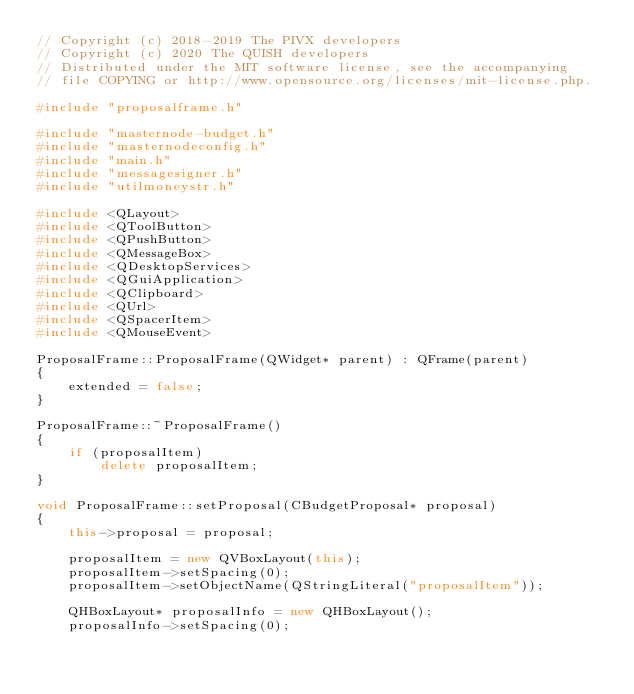<code> <loc_0><loc_0><loc_500><loc_500><_C++_>// Copyright (c) 2018-2019 The PIVX developers
// Copyright (c) 2020 The QUISH developers
// Distributed under the MIT software license, see the accompanying
// file COPYING or http://www.opensource.org/licenses/mit-license.php.

#include "proposalframe.h"

#include "masternode-budget.h"
#include "masternodeconfig.h"
#include "main.h"
#include "messagesigner.h"
#include "utilmoneystr.h"

#include <QLayout>
#include <QToolButton>
#include <QPushButton>
#include <QMessageBox>
#include <QDesktopServices>
#include <QGuiApplication>
#include <QClipboard>
#include <QUrl>
#include <QSpacerItem>
#include <QMouseEvent>

ProposalFrame::ProposalFrame(QWidget* parent) : QFrame(parent)
{
    extended = false;
}

ProposalFrame::~ProposalFrame()
{
    if (proposalItem)
        delete proposalItem;
}

void ProposalFrame::setProposal(CBudgetProposal* proposal)
{
    this->proposal = proposal;

    proposalItem = new QVBoxLayout(this);
    proposalItem->setSpacing(0);
    proposalItem->setObjectName(QStringLiteral("proposalItem"));

    QHBoxLayout* proposalInfo = new QHBoxLayout();
    proposalInfo->setSpacing(0);</code> 